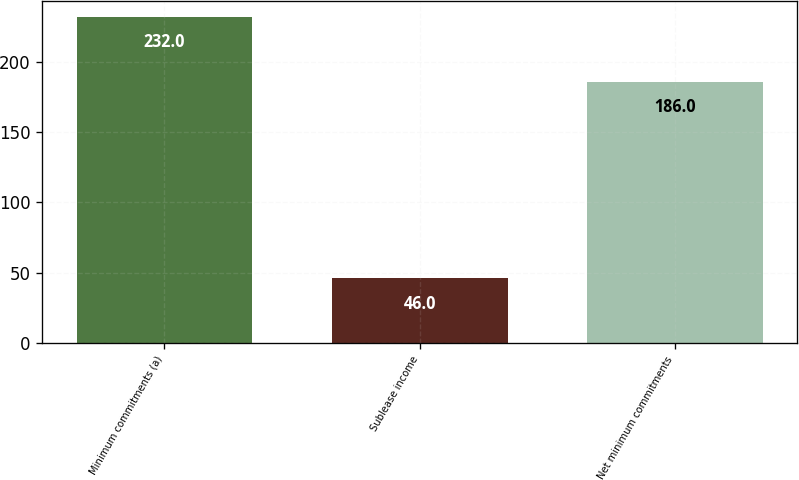Convert chart. <chart><loc_0><loc_0><loc_500><loc_500><bar_chart><fcel>Minimum commitments (a)<fcel>Sublease income<fcel>Net minimum commitments<nl><fcel>232<fcel>46<fcel>186<nl></chart> 